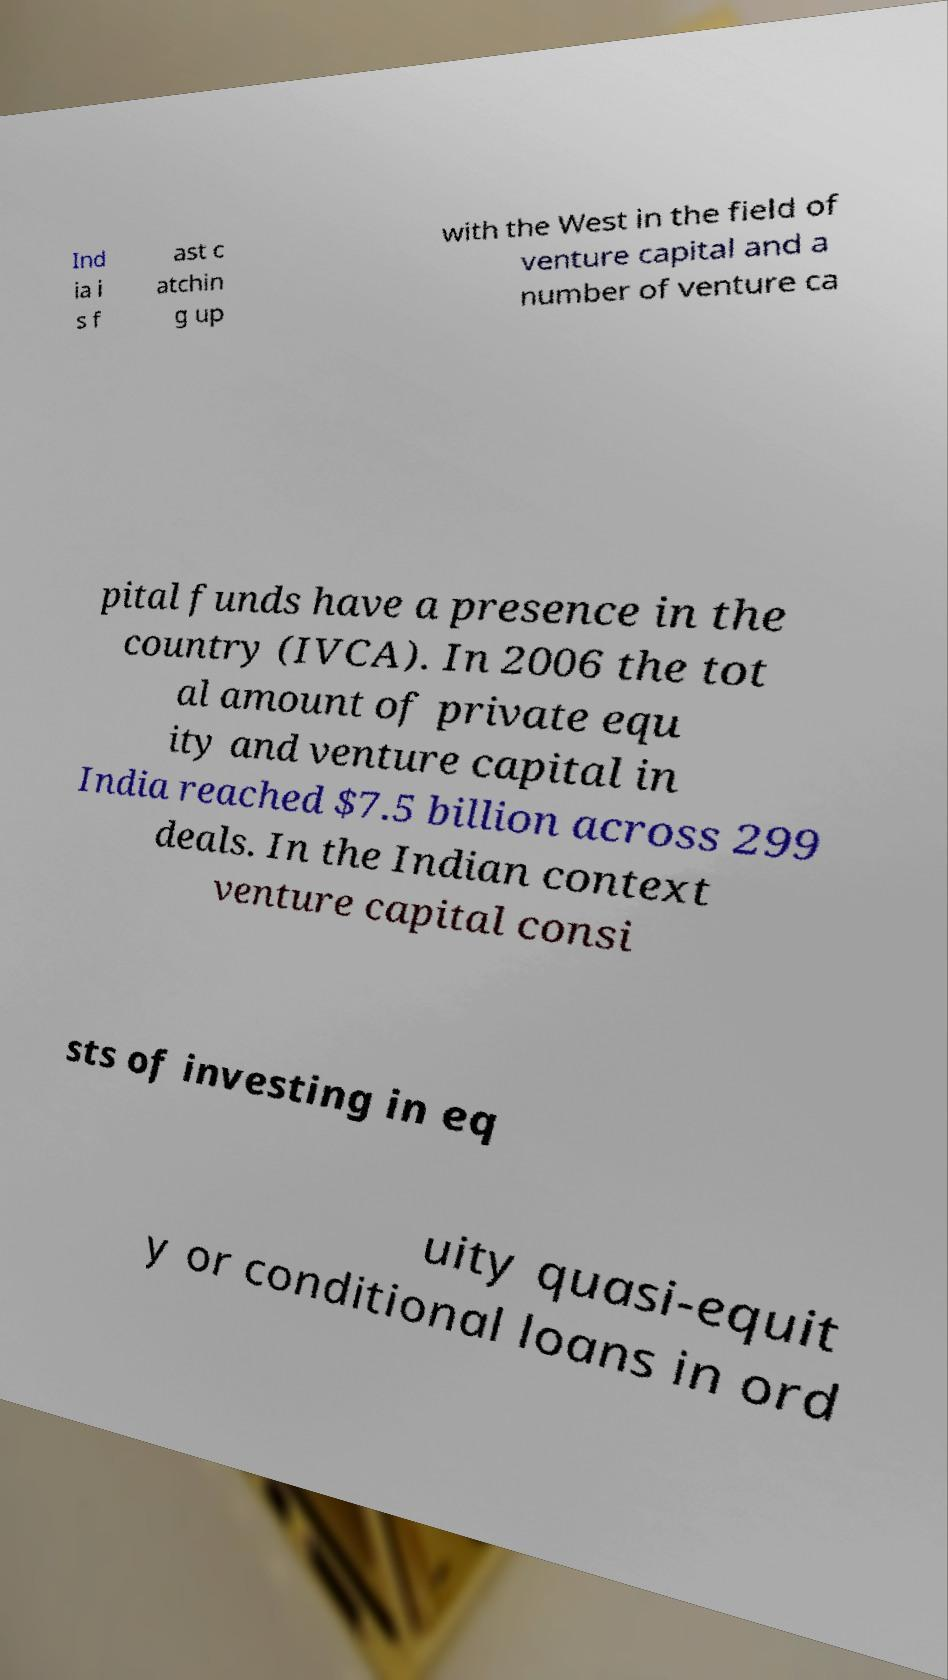Please identify and transcribe the text found in this image. Ind ia i s f ast c atchin g up with the West in the field of venture capital and a number of venture ca pital funds have a presence in the country (IVCA). In 2006 the tot al amount of private equ ity and venture capital in India reached $7.5 billion across 299 deals. In the Indian context venture capital consi sts of investing in eq uity quasi-equit y or conditional loans in ord 